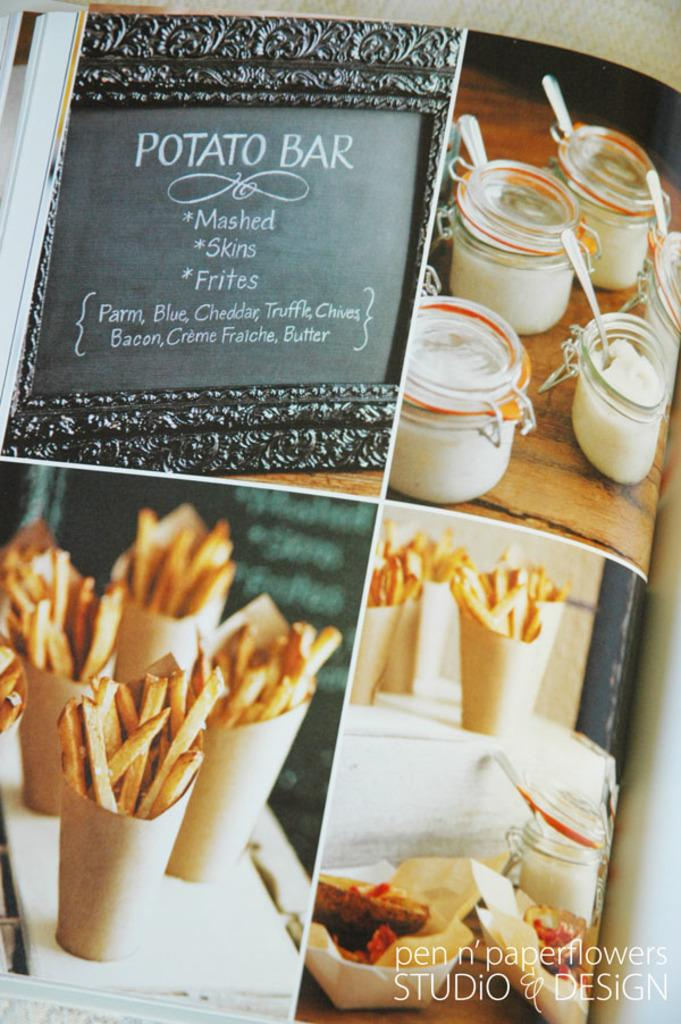What is the main subject of the image? The main subject of the image is a poster. What is depicted on the poster? The poster contains food items and bowls. Are there any other objects visible on the poster? Yes, there are other objects visible on the poster. Where is the text located in the image? The text is in the bottom right corner of the image. What type of sky is depicted in the image? There is no sky depicted in the image; it features a poster with food items, bowls, and other objects. Can you tell me what day of the week it is from the calendar in the image? There is no calendar present in the image; it features a poster with food items, bowls, and other objects. 